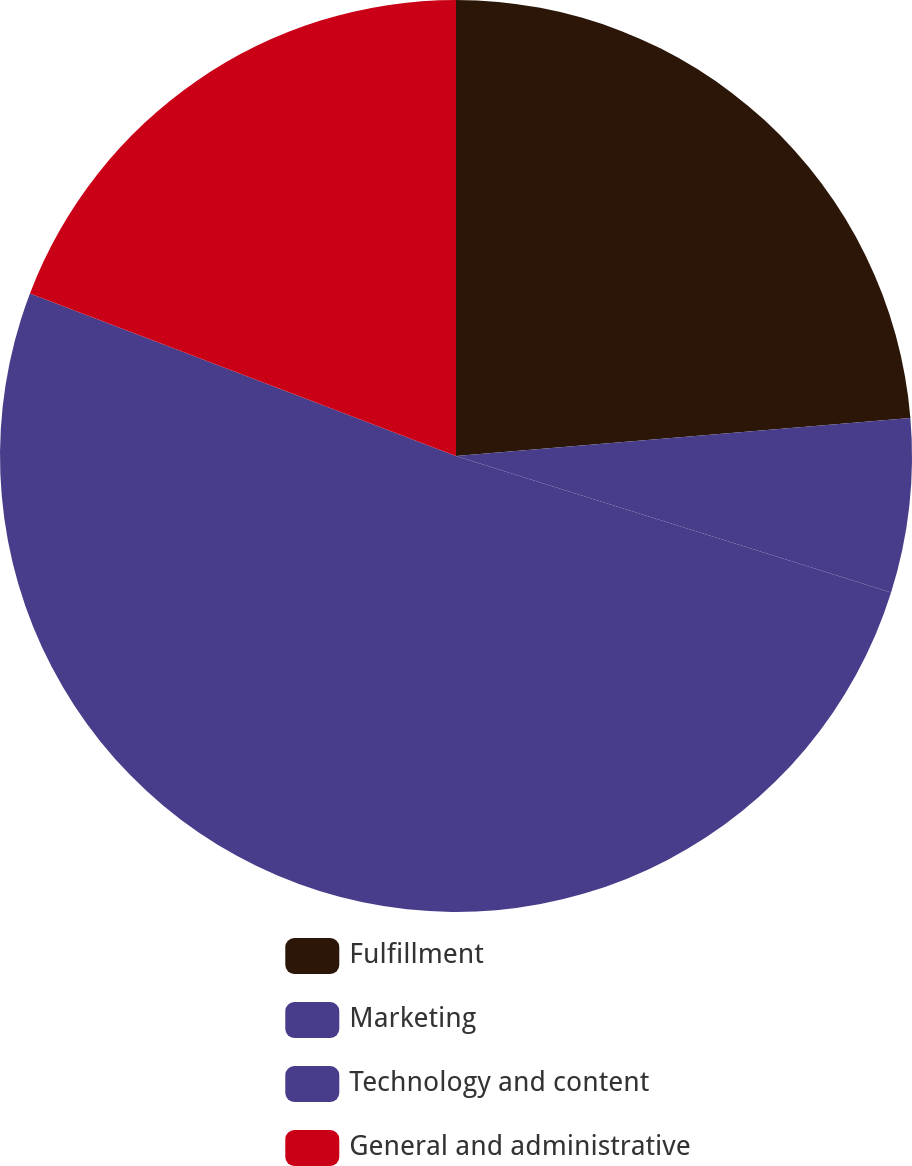Convert chart to OTSL. <chart><loc_0><loc_0><loc_500><loc_500><pie_chart><fcel>Fulfillment<fcel>Marketing<fcel>Technology and content<fcel>General and administrative<nl><fcel>23.67%<fcel>6.17%<fcel>50.96%<fcel>19.2%<nl></chart> 